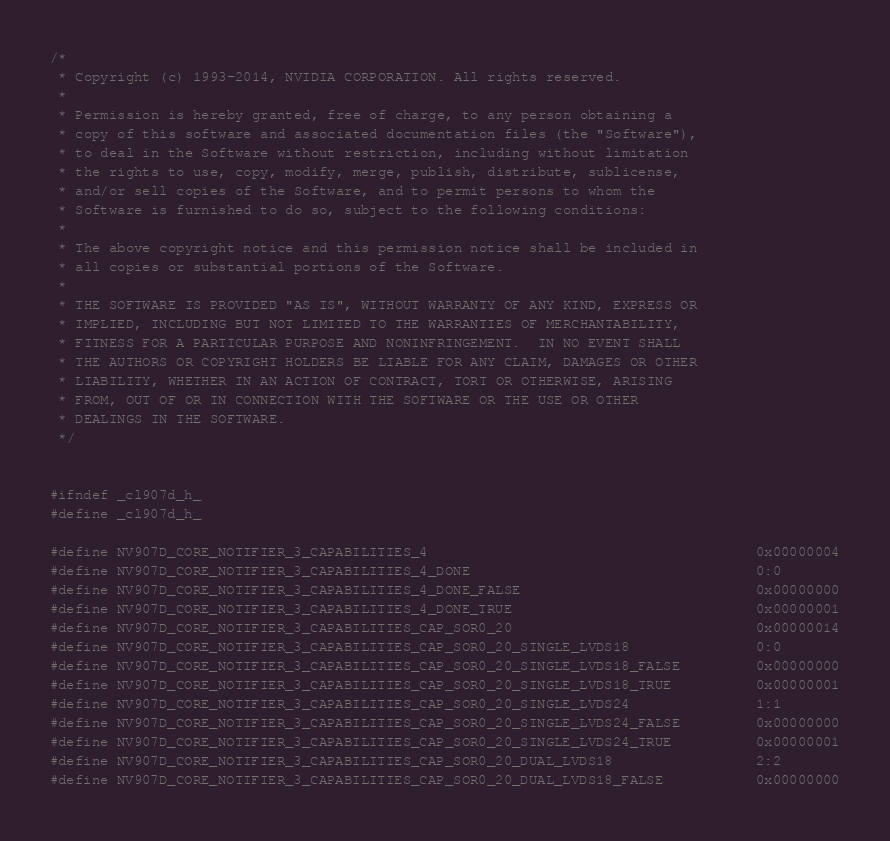<code> <loc_0><loc_0><loc_500><loc_500><_C_>/*
 * Copyright (c) 1993-2014, NVIDIA CORPORATION. All rights reserved.
 *
 * Permission is hereby granted, free of charge, to any person obtaining a
 * copy of this software and associated documentation files (the "Software"),
 * to deal in the Software without restriction, including without limitation
 * the rights to use, copy, modify, merge, publish, distribute, sublicense,
 * and/or sell copies of the Software, and to permit persons to whom the
 * Software is furnished to do so, subject to the following conditions:
 *
 * The above copyright notice and this permission notice shall be included in
 * all copies or substantial portions of the Software.
 *
 * THE SOFTWARE IS PROVIDED "AS IS", WITHOUT WARRANTY OF ANY KIND, EXPRESS OR
 * IMPLIED, INCLUDING BUT NOT LIMITED TO THE WARRANTIES OF MERCHANTABILITY,
 * FITNESS FOR A PARTICULAR PURPOSE AND NONINFRINGEMENT.  IN NO EVENT SHALL
 * THE AUTHORS OR COPYRIGHT HOLDERS BE LIABLE FOR ANY CLAIM, DAMAGES OR OTHER
 * LIABILITY, WHETHER IN AN ACTION OF CONTRACT, TORT OR OTHERWISE, ARISING
 * FROM, OUT OF OR IN CONNECTION WITH THE SOFTWARE OR THE USE OR OTHER
 * DEALINGS IN THE SOFTWARE.
 */


#ifndef _cl907d_h_
#define _cl907d_h_

#define NV907D_CORE_NOTIFIER_3_CAPABILITIES_4                                       0x00000004
#define NV907D_CORE_NOTIFIER_3_CAPABILITIES_4_DONE                                  0:0
#define NV907D_CORE_NOTIFIER_3_CAPABILITIES_4_DONE_FALSE                            0x00000000
#define NV907D_CORE_NOTIFIER_3_CAPABILITIES_4_DONE_TRUE                             0x00000001
#define NV907D_CORE_NOTIFIER_3_CAPABILITIES_CAP_SOR0_20                             0x00000014
#define NV907D_CORE_NOTIFIER_3_CAPABILITIES_CAP_SOR0_20_SINGLE_LVDS18               0:0
#define NV907D_CORE_NOTIFIER_3_CAPABILITIES_CAP_SOR0_20_SINGLE_LVDS18_FALSE         0x00000000
#define NV907D_CORE_NOTIFIER_3_CAPABILITIES_CAP_SOR0_20_SINGLE_LVDS18_TRUE          0x00000001
#define NV907D_CORE_NOTIFIER_3_CAPABILITIES_CAP_SOR0_20_SINGLE_LVDS24               1:1
#define NV907D_CORE_NOTIFIER_3_CAPABILITIES_CAP_SOR0_20_SINGLE_LVDS24_FALSE         0x00000000
#define NV907D_CORE_NOTIFIER_3_CAPABILITIES_CAP_SOR0_20_SINGLE_LVDS24_TRUE          0x00000001
#define NV907D_CORE_NOTIFIER_3_CAPABILITIES_CAP_SOR0_20_DUAL_LVDS18                 2:2
#define NV907D_CORE_NOTIFIER_3_CAPABILITIES_CAP_SOR0_20_DUAL_LVDS18_FALSE           0x00000000</code> 